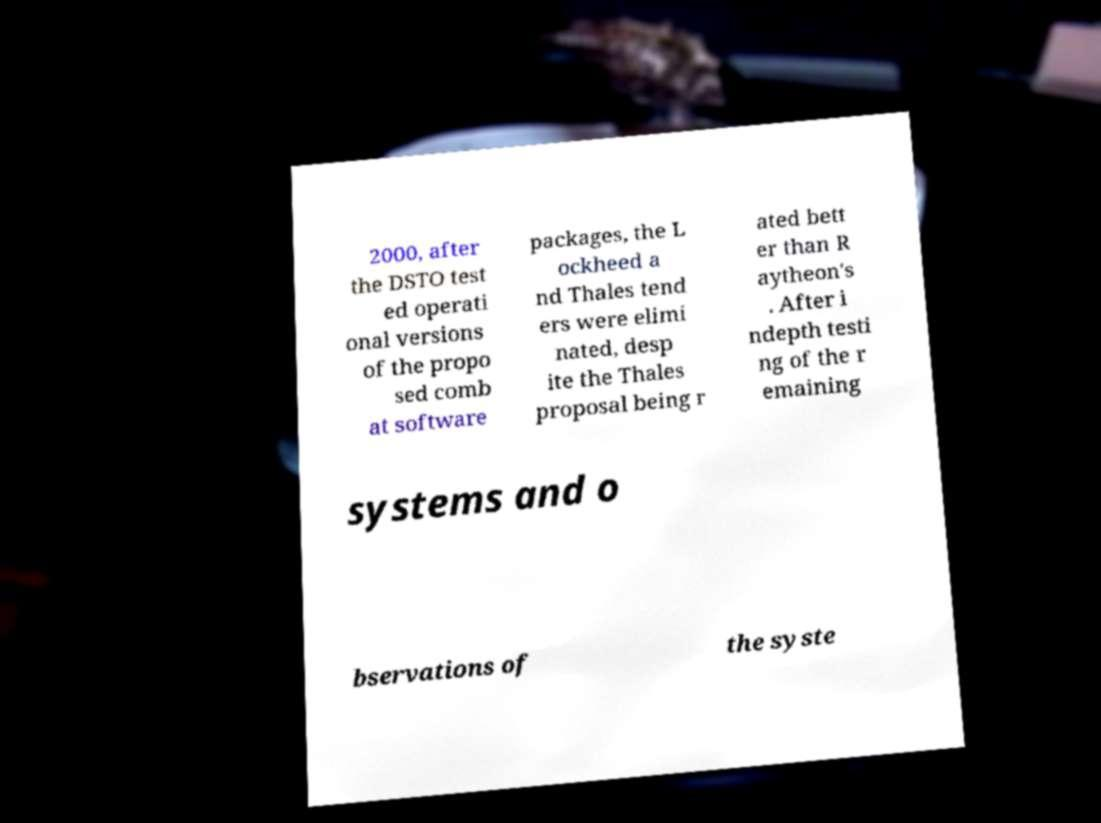There's text embedded in this image that I need extracted. Can you transcribe it verbatim? 2000, after the DSTO test ed operati onal versions of the propo sed comb at software packages, the L ockheed a nd Thales tend ers were elimi nated, desp ite the Thales proposal being r ated bett er than R aytheon's . After i ndepth testi ng of the r emaining systems and o bservations of the syste 